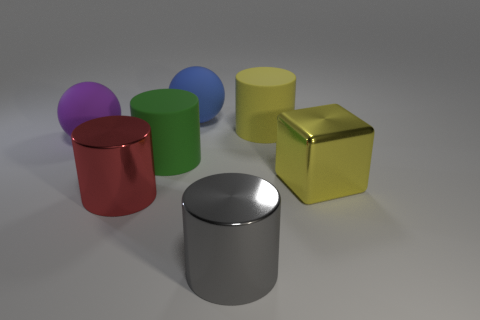There is a object that is the same color as the cube; what is its size?
Your answer should be very brief. Large. What shape is the yellow thing that is behind the large metal thing that is on the right side of the yellow object on the left side of the yellow block?
Your response must be concise. Cylinder. What material is the thing that is left of the large yellow cylinder and behind the purple rubber sphere?
Offer a terse response. Rubber. There is a metal cylinder that is on the left side of the metallic cylinder right of the shiny cylinder that is to the left of the green thing; what color is it?
Your answer should be very brief. Red. How many cyan things are cylinders or big matte balls?
Your answer should be compact. 0. What number of other things are there of the same size as the gray thing?
Make the answer very short. 6. How many large green things are there?
Give a very brief answer. 1. Is there any other thing that has the same shape as the green rubber thing?
Keep it short and to the point. Yes. Do the sphere behind the purple rubber ball and the big object that is in front of the big red object have the same material?
Keep it short and to the point. No. What is the red cylinder made of?
Provide a short and direct response. Metal. 